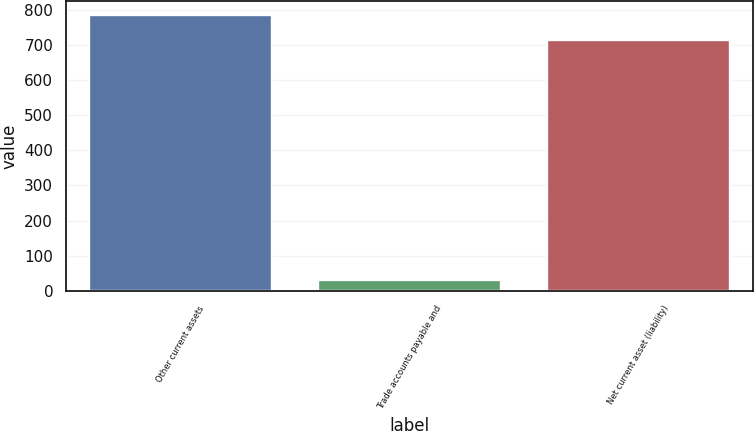Convert chart to OTSL. <chart><loc_0><loc_0><loc_500><loc_500><bar_chart><fcel>Other current assets<fcel>Trade accounts payable and<fcel>Net current asset (liability)<nl><fcel>784.3<fcel>30<fcel>713<nl></chart> 